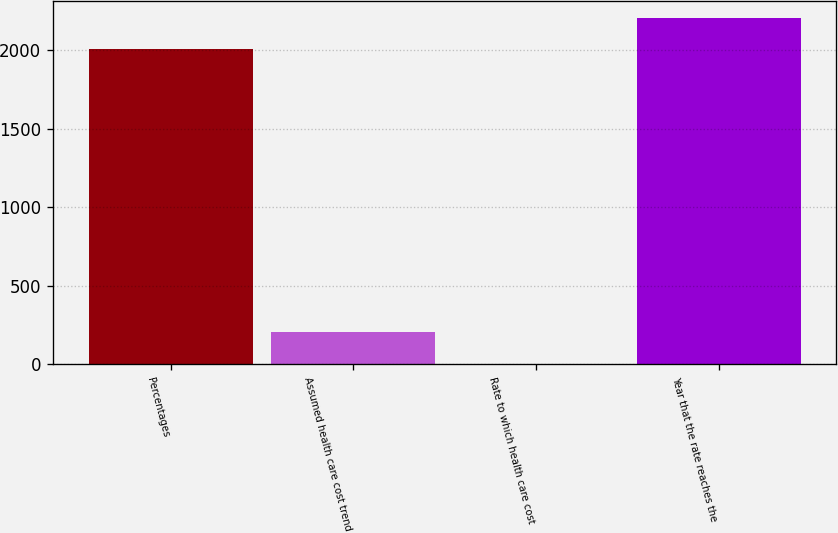Convert chart to OTSL. <chart><loc_0><loc_0><loc_500><loc_500><bar_chart><fcel>Percentages<fcel>Assumed health care cost trend<fcel>Rate to which health care cost<fcel>Year that the rate reaches the<nl><fcel>2005<fcel>205.5<fcel>5<fcel>2205.5<nl></chart> 